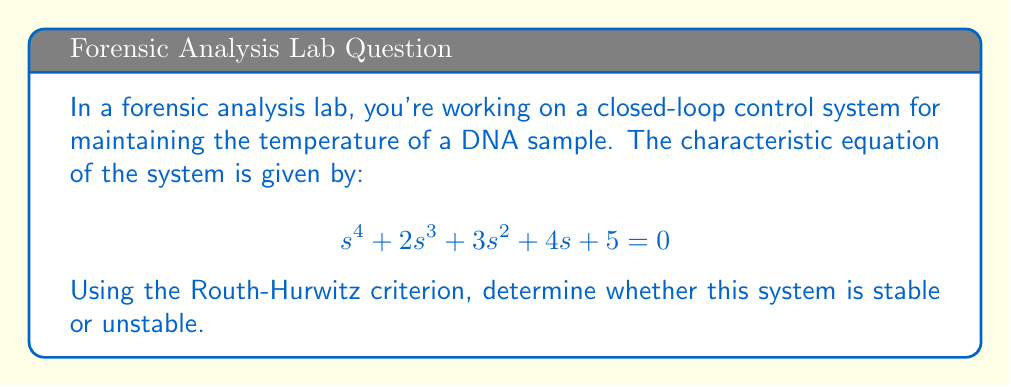What is the answer to this math problem? To analyze the stability of the system using the Routh-Hurwitz criterion, we need to construct the Routh array and examine the signs of the first column. Here's the step-by-step process:

1. Write out the coefficients of the characteristic equation in descending order:
   $$s^4: 1$$
   $$s^3: 2$$
   $$s^2: 3$$
   $$s^1: 4$$
   $$s^0: 5$$

2. Construct the Routh array:

   $$\begin{array}{c|cc}
   s^4 & 1 & 3 & 5 \\
   s^3 & 2 & 4 & 0 \\
   s^2 & b_1 & b_2 & \\
   s^1 & c_1 & & \\
   s^0 & d_1 & &
   \end{array}$$

3. Calculate the values for $b_1$, $b_2$, $c_1$, and $d_1$:

   $b_1 = \frac{(2)(3) - (1)(4)}{2} = 1$

   $b_2 = \frac{(2)(5) - (1)(0)}{2} = 5$

   $c_1 = \frac{(1)(4) - (2)(5)}{1} = -6$

   $d_1 = 5$ (last coefficient of the characteristic equation)

4. Complete the Routh array:

   $$\begin{array}{c|cc}
   s^4 & 1 & 3 & 5 \\
   s^3 & 2 & 4 & 0 \\
   s^2 & 1 & 5 & \\
   s^1 & -6 & & \\
   s^0 & 5 & &
   \end{array}$$

5. Examine the signs of the first column:
   The first column contains both positive and negative values (1, 2, 1, -6, 5).

6. Interpret the results:
   For a system to be stable, all elements in the first column of the Routh array must have the same sign (all positive or all negative). In this case, we have a sign change in the first column, indicating that the system is unstable.
Answer: The system is unstable because there is a sign change in the first column of the Routh array. 